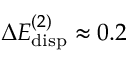<formula> <loc_0><loc_0><loc_500><loc_500>\Delta E _ { d i s p } ^ { ( 2 ) } \approx 0 . 2</formula> 